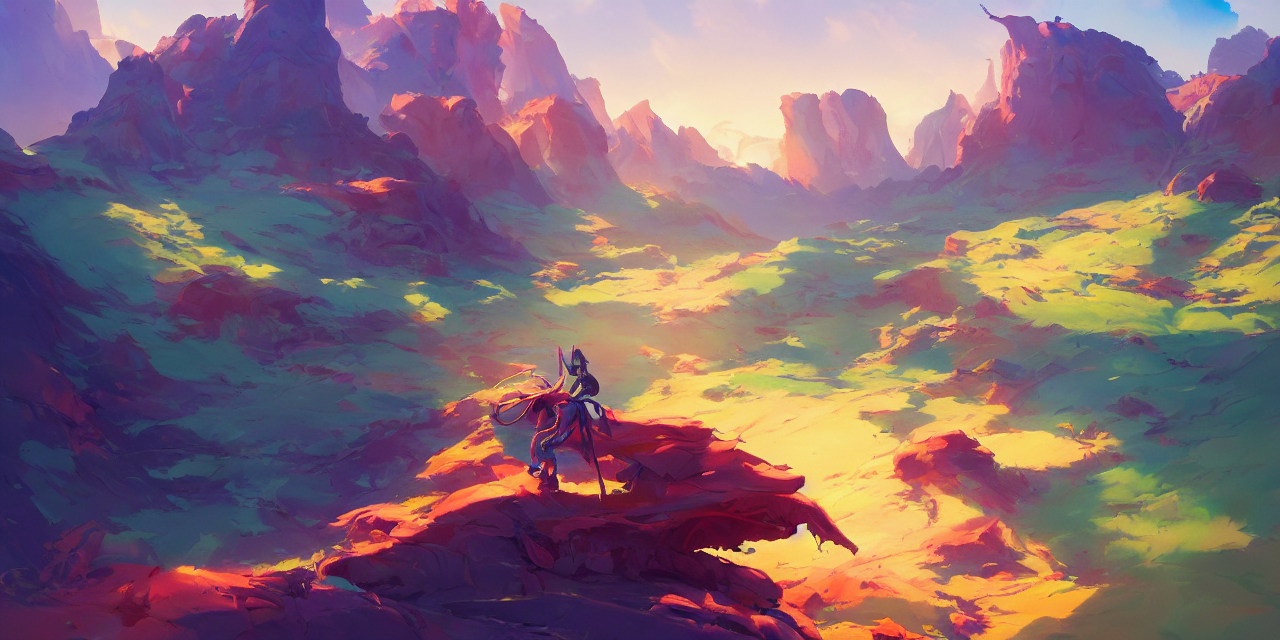What feeling does this image evoke? The image evokes a profound sense of solitude and introspection, as the singular figure atop the outcropping overlooks the vast wilderness. There's also a feeling of adventure and the unknown, hinted at by the untamed and unexplored terrain. 